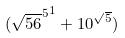<formula> <loc_0><loc_0><loc_500><loc_500>( { \sqrt { 5 6 } ^ { 5 } } ^ { 1 } + 1 0 ^ { \sqrt { 5 } } )</formula> 